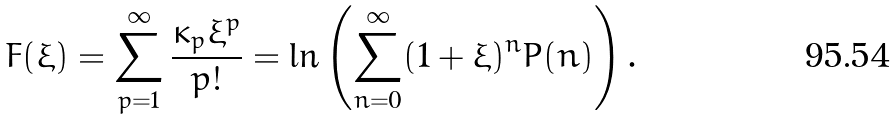Convert formula to latex. <formula><loc_0><loc_0><loc_500><loc_500>F ( \xi ) = \sum _ { p = 1 } ^ { \infty } \frac { \kappa _ { p } \xi ^ { p } } { p ! } = \ln \left ( \sum _ { n = 0 } ^ { \infty } ( 1 + \xi ) ^ { n } P ( n ) \right ) .</formula> 